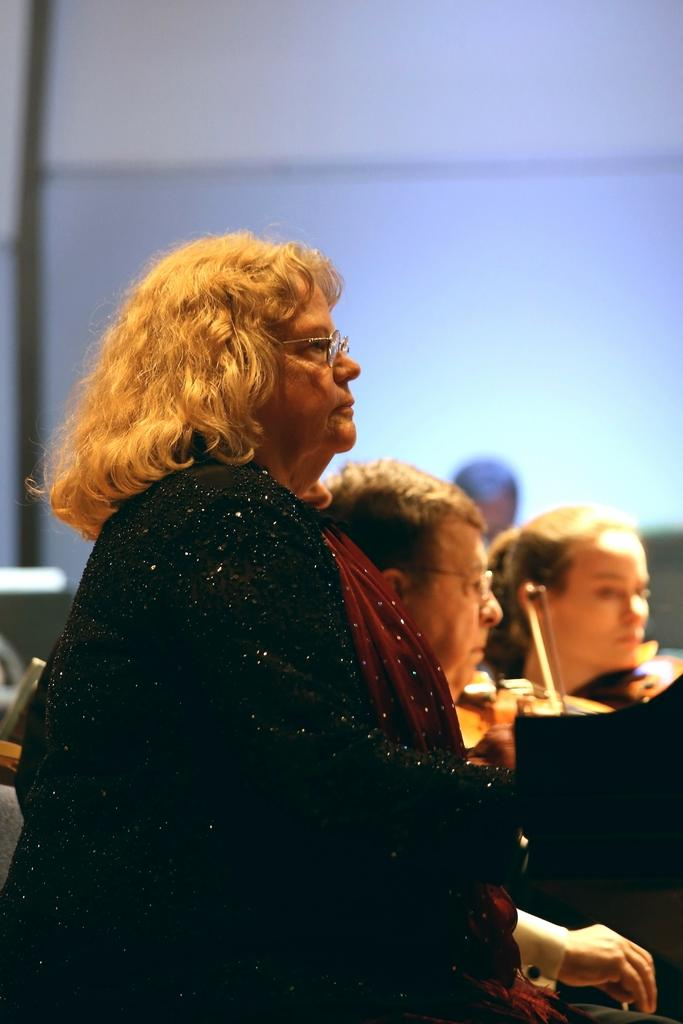What is happening in the center of the image? There are persons in the center of the image. What are some of the persons doing? Some of the persons are playing guitar. What can be seen in the background of the image? There is a wall visible in the background of the image. Can you see any cherries on the guitar in the image? There are no cherries visible on the guitar in the image. What type of test is being conducted in the image? There is no test being conducted in the image; it features persons playing guitar. 